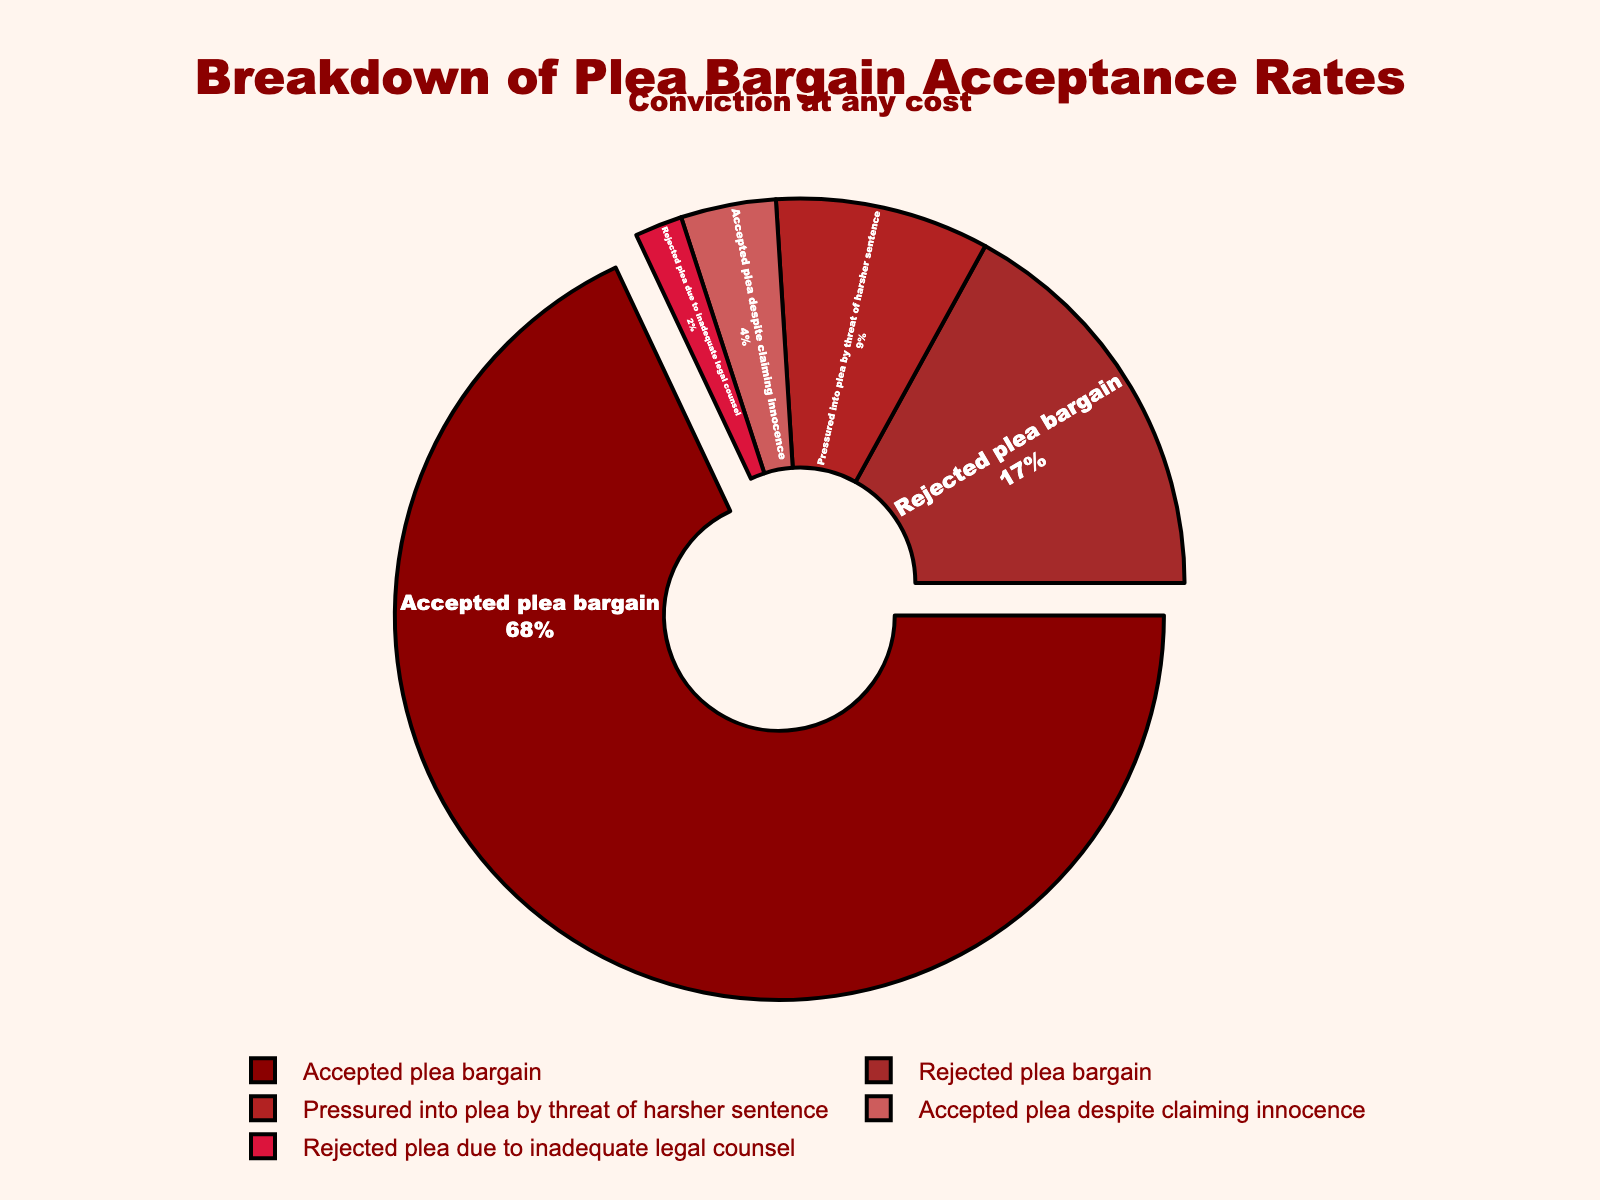What percentage of defendants accepted the plea bargain? The figure shows a pie chart with different categories. The segment labeled "Accepted plea bargain" indicates the percentage of defendants who accepted the plea bargain.
Answer: 68% What is the combined percentage of defendants who rejected the plea bargain and those who rejected it due to inadequate legal counsel? Add the percentage of the category labeled "Rejected plea bargain" (17%) to the percentage labeled "Rejected plea due to inadequate legal counsel" (2%). This gives 17% + 2%.
Answer: 19% Which category has the smallest percentage, and what is that percentage? By examining the pie chart, the segment labeled "Rejected plea due to inadequate legal counsel" represents the smallest portion.
Answer: Rejected plea due to inadequate legal counsel, 2% How does the percentage of defendants pressured into a plea by threat of a harsher sentence compare to those who accepted the plea despite claiming innocence? Look at the pie chart segments for "Pressured into plea by threat of harsher sentence" (9%) and "Accepted plea despite claiming innocence" (4%). 9% is greater than 4%.
Answer: Pressured into plea by threat of harsher sentence has a greater percentage What percentage more defendants accepted a plea bargain compared to those who rejected it? Subtract the percentage of "Rejected plea bargain" (17%) from "Accepted plea bargain" (68%). This gives 68% - 17%.
Answer: 51% What two categories together make up less than 10% of the total? Identify categories with percentages summing to less than 10%. "Rejected plea due to inadequate legal counsel" (2%) and "Accepted plea despite claiming innocence" (4%) together add up to 6%.
Answer: Rejected plea due to inadequate legal counsel and Accepted plea despite claiming innocence What is the total percentage of defendants who either accepted a plea bargain or were pressured into a plea by a threat of a harsher sentence? Add the percentage for "Accepted plea bargain" (68%) to the percentage for "Pressured into plea by threat of harsher sentence" (9%). This gives 68% + 9%.
Answer: 77% What visual feature helps highlight the category "Accepted plea bargain"? The segment for "Accepted plea bargain" is slightly pulled out from the pie chart, making it more prominent.
Answer: The segment is pulled out 